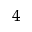<formula> <loc_0><loc_0><loc_500><loc_500>_ { 4 }</formula> 